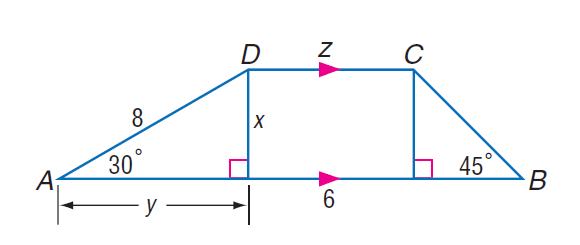Answer the mathemtical geometry problem and directly provide the correct option letter.
Question: Find y.
Choices: A: 4 B: 4 \sqrt { 3 } C: 8 D: 8 \sqrt { 3 } B 